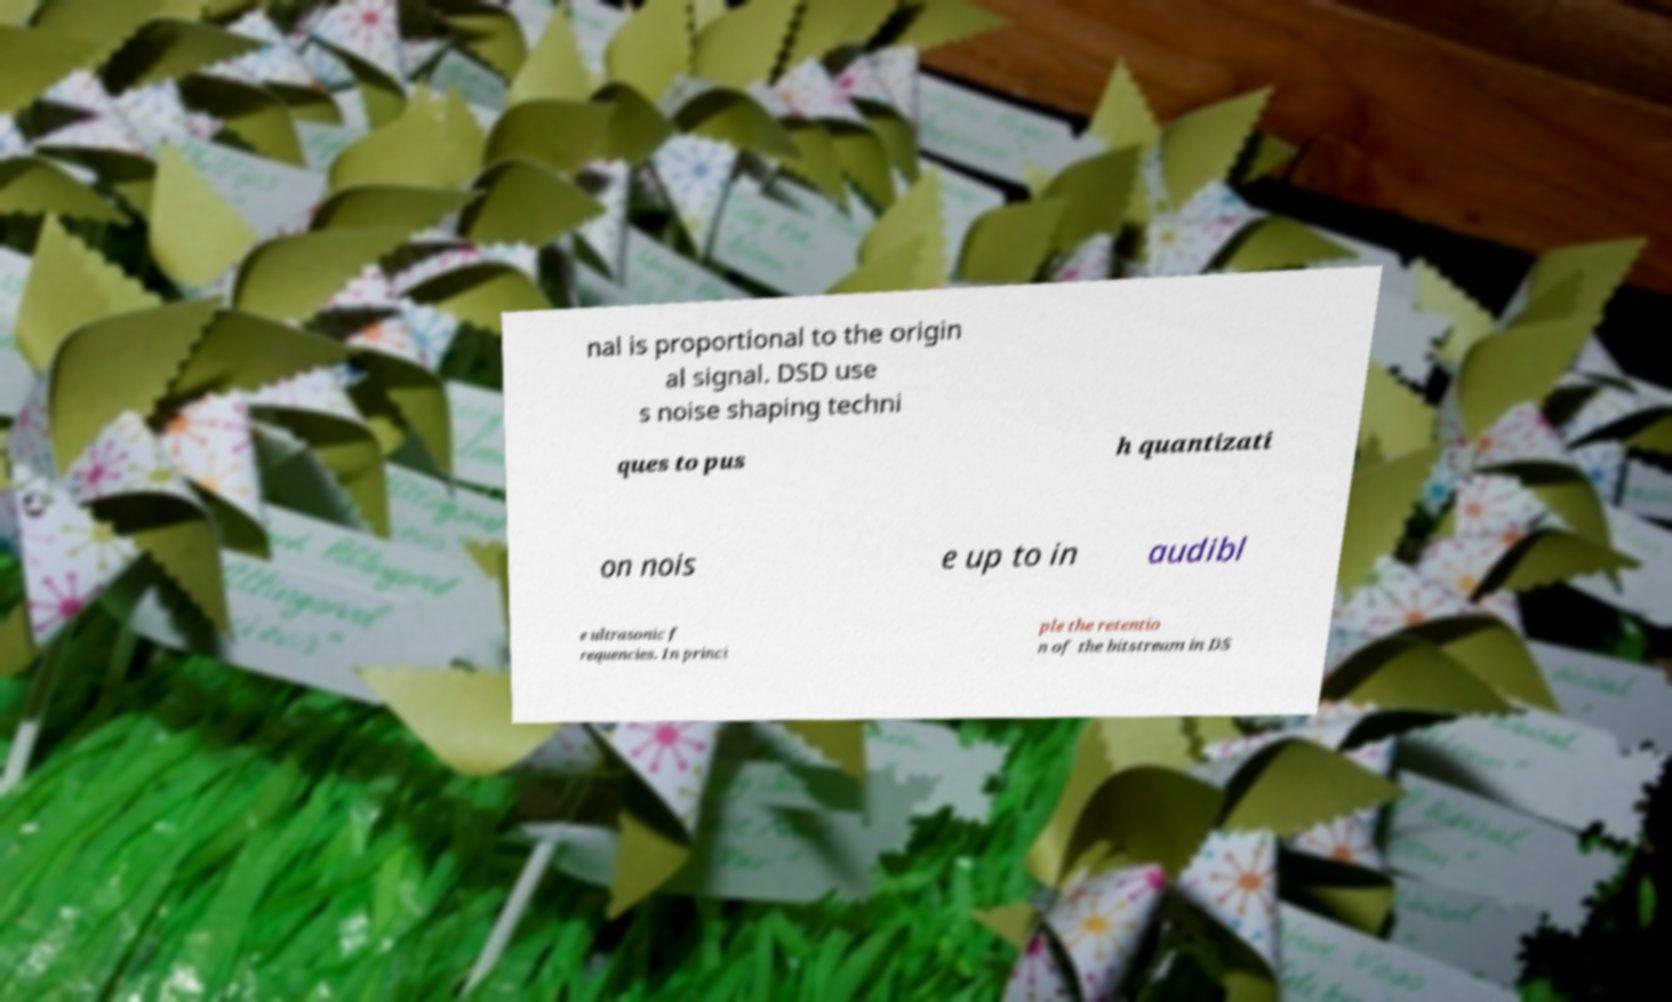For documentation purposes, I need the text within this image transcribed. Could you provide that? nal is proportional to the origin al signal. DSD use s noise shaping techni ques to pus h quantizati on nois e up to in audibl e ultrasonic f requencies. In princi ple the retentio n of the bitstream in DS 